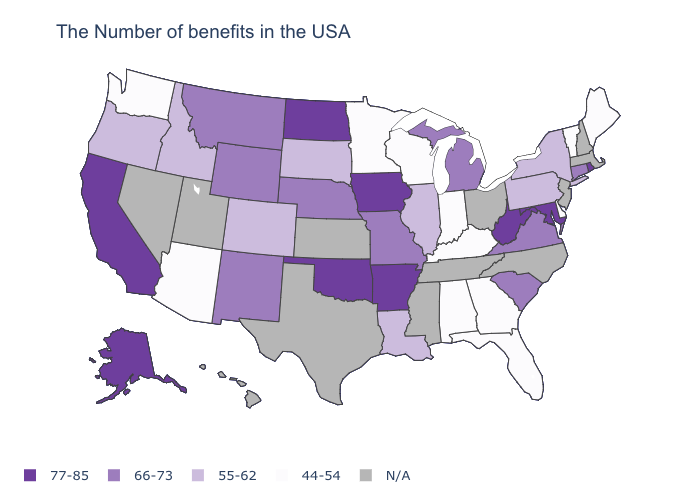What is the highest value in the USA?
Be succinct. 77-85. Does the map have missing data?
Be succinct. Yes. What is the value of Utah?
Answer briefly. N/A. Name the states that have a value in the range 44-54?
Quick response, please. Maine, Vermont, Delaware, Florida, Georgia, Kentucky, Indiana, Alabama, Wisconsin, Minnesota, Arizona, Washington. What is the value of Delaware?
Give a very brief answer. 44-54. Name the states that have a value in the range 55-62?
Quick response, please. New York, Pennsylvania, Illinois, Louisiana, South Dakota, Colorado, Idaho, Oregon. Name the states that have a value in the range 55-62?
Keep it brief. New York, Pennsylvania, Illinois, Louisiana, South Dakota, Colorado, Idaho, Oregon. What is the value of Nevada?
Answer briefly. N/A. What is the value of Alabama?
Concise answer only. 44-54. What is the value of New Hampshire?
Give a very brief answer. N/A. What is the highest value in the South ?
Answer briefly. 77-85. What is the value of Kentucky?
Short answer required. 44-54. Which states have the lowest value in the USA?
Write a very short answer. Maine, Vermont, Delaware, Florida, Georgia, Kentucky, Indiana, Alabama, Wisconsin, Minnesota, Arizona, Washington. Name the states that have a value in the range 77-85?
Keep it brief. Rhode Island, Maryland, West Virginia, Arkansas, Iowa, Oklahoma, North Dakota, California, Alaska. What is the value of Nevada?
Keep it brief. N/A. 